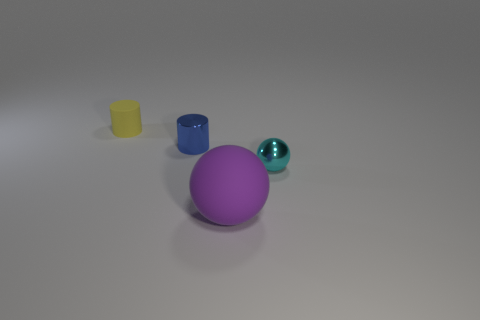Add 3 large rubber objects. How many objects exist? 7 Add 4 purple spheres. How many purple spheres are left? 5 Add 3 tiny cyan metal spheres. How many tiny cyan metal spheres exist? 4 Subtract all yellow cylinders. How many cylinders are left? 1 Subtract 0 red cylinders. How many objects are left? 4 Subtract 2 balls. How many balls are left? 0 Subtract all yellow balls. Subtract all green cylinders. How many balls are left? 2 Subtract all yellow cubes. How many gray spheres are left? 0 Subtract all big gray metal blocks. Subtract all tiny blue cylinders. How many objects are left? 3 